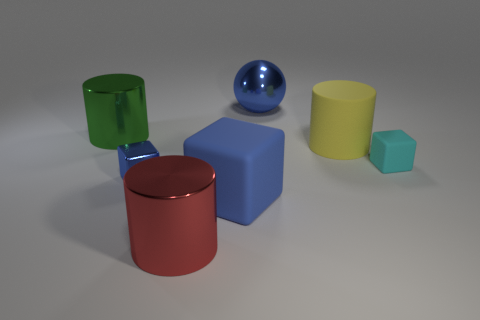What number of balls are small blue metal objects or yellow rubber objects?
Your response must be concise. 0. The large matte cylinder is what color?
Keep it short and to the point. Yellow. Are there more red cylinders than large yellow shiny objects?
Make the answer very short. Yes. What number of objects are either large cylinders to the right of the blue metallic ball or large green metal objects?
Your response must be concise. 2. Is the red thing made of the same material as the blue ball?
Offer a very short reply. Yes. There is a red metallic object that is the same shape as the green thing; what size is it?
Your answer should be very brief. Large. There is a big matte thing in front of the yellow object; does it have the same shape as the blue object behind the small metal object?
Give a very brief answer. No. There is a shiny block; does it have the same size as the blue thing behind the small matte block?
Ensure brevity in your answer.  No. How many other objects are there of the same material as the red thing?
Your answer should be very brief. 3. Is there any other thing that has the same shape as the tiny rubber thing?
Offer a terse response. Yes. 